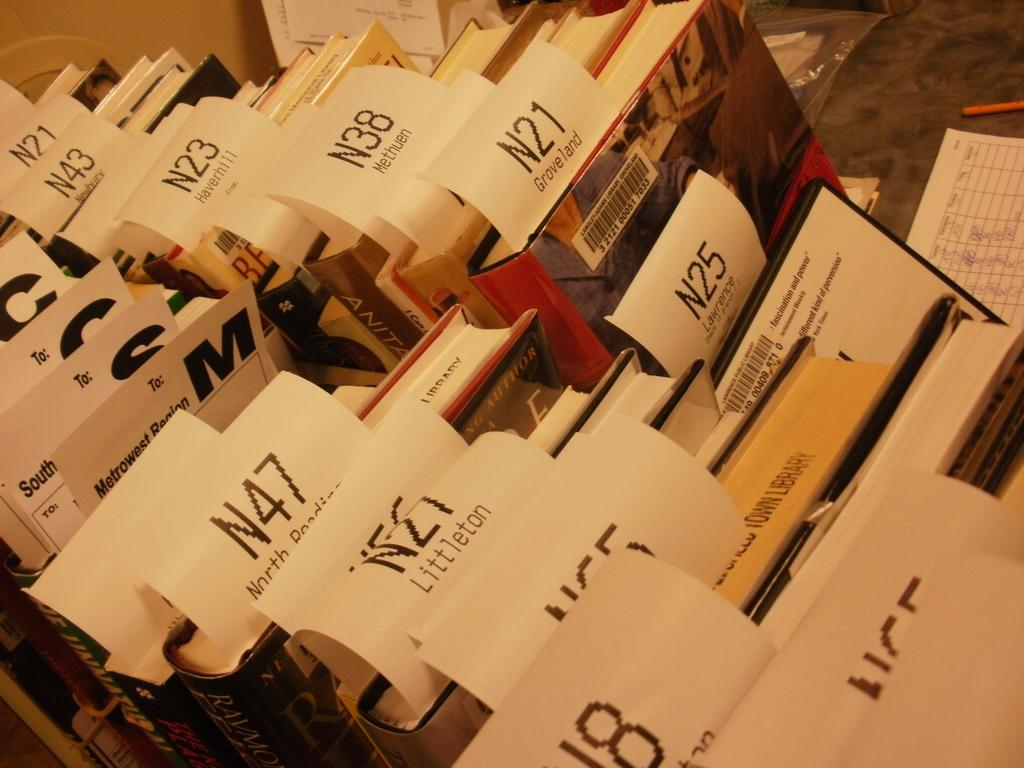<image>
Create a compact narrative representing the image presented. Tags with identifiers like N25, N21 and N38 stick out of an assorted collection of books. 